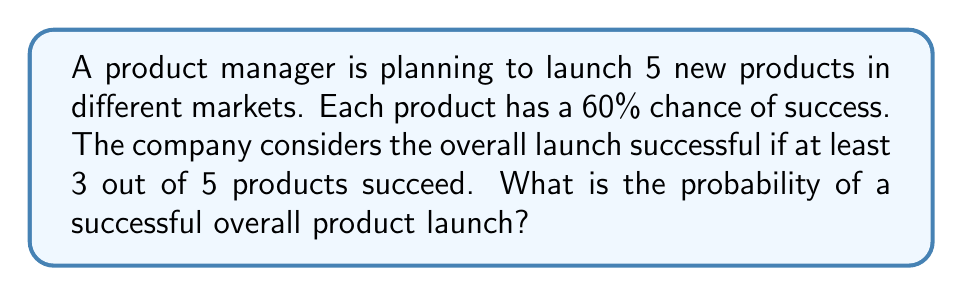Can you solve this math problem? Let's approach this step-by-step using combinatorial techniques:

1) First, we need to identify the probability distribution. This scenario follows a binomial distribution, where we have:
   - n = 5 (number of trials/products)
   - p = 0.6 (probability of success for each product)
   - We want at least 3 successes

2) The probability of a successful overall launch is the sum of probabilities of having 3, 4, or 5 successful products.

3) For each case, we'll use the binomial probability formula:

   $$P(X = k) = \binom{n}{k} p^k (1-p)^{n-k}$$

   Where:
   - n = 5 (total number of products)
   - k = number of successful products (3, 4, or 5)
   - p = 0.6 (probability of success for each product)

4) Let's calculate each case:

   For 3 successes:
   $$P(X = 3) = \binom{5}{3} (0.6)^3 (0.4)^2 = 10 \times 0.216 \times 0.16 = 0.3456$$

   For 4 successes:
   $$P(X = 4) = \binom{5}{4} (0.6)^4 (0.4)^1 = 5 \times 0.1296 \times 0.4 = 0.2592$$

   For 5 successes:
   $$P(X = 5) = \binom{5}{5} (0.6)^5 (0.4)^0 = 1 \times 0.07776 \times 1 = 0.07776$$

5) The total probability is the sum of these three probabilities:

   $$P(\text{at least 3 successes}) = 0.3456 + 0.2592 + 0.07776 = 0.68256$$

6) Therefore, the probability of a successful overall product launch is approximately 0.6826 or 68.26%.
Answer: 0.68256 